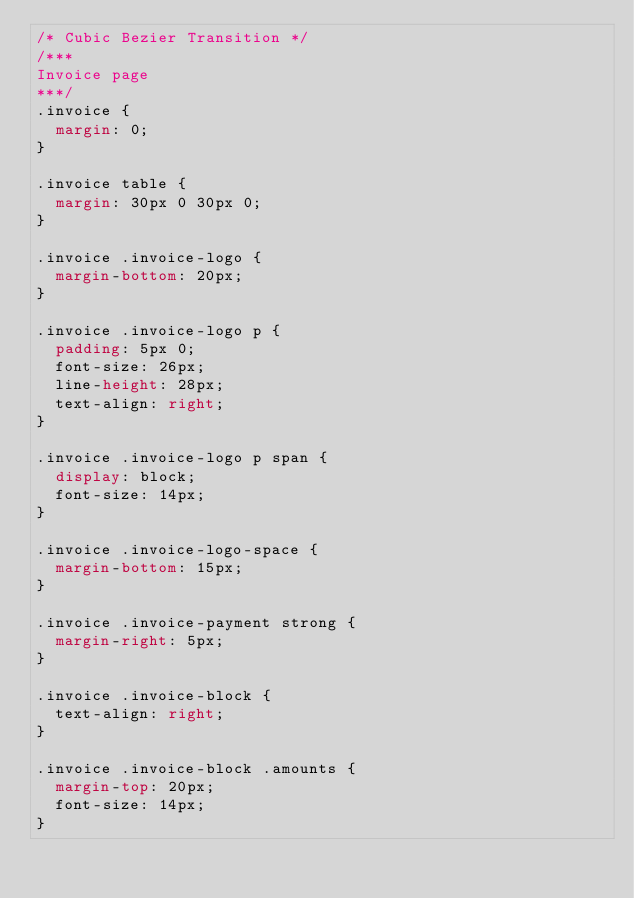Convert code to text. <code><loc_0><loc_0><loc_500><loc_500><_CSS_>/* Cubic Bezier Transition */
/***
Invoice page
***/
.invoice {
	margin: 0;
}

.invoice table {
	margin: 30px 0 30px 0;
}

.invoice .invoice-logo {
	margin-bottom: 20px;
}

.invoice .invoice-logo p {
	padding: 5px 0;
	font-size: 26px;
	line-height: 28px;
	text-align: right;
}

.invoice .invoice-logo p span {
	display: block;
	font-size: 14px;
}

.invoice .invoice-logo-space {
	margin-bottom: 15px;
}

.invoice .invoice-payment strong {
	margin-right: 5px;
}

.invoice .invoice-block {
	text-align: right;
}

.invoice .invoice-block .amounts {
	margin-top: 20px;
	font-size: 14px;
}</code> 